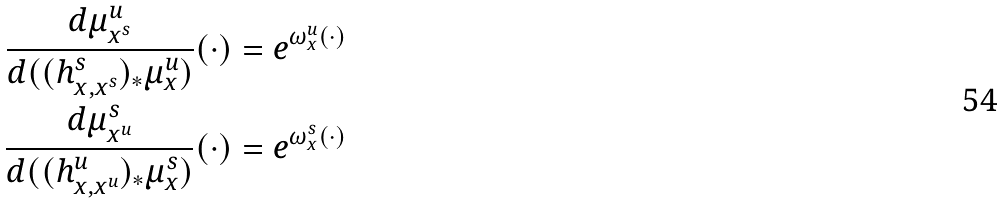Convert formula to latex. <formula><loc_0><loc_0><loc_500><loc_500>\frac { d \mu ^ { u } _ { x ^ { s } } } { d ( ( h ^ { s } _ { x , x ^ { s } } ) _ { * } \mu ^ { u } _ { x } ) } ( \cdot ) & = e ^ { \omega _ { x } ^ { u } ( \cdot ) } \\ \frac { d \mu ^ { s } _ { x ^ { u } } } { d ( ( h ^ { u } _ { x , x ^ { u } } ) _ { * } \mu ^ { s } _ { x } ) } ( \cdot ) & = e ^ { \omega _ { x } ^ { s } ( \cdot ) }</formula> 